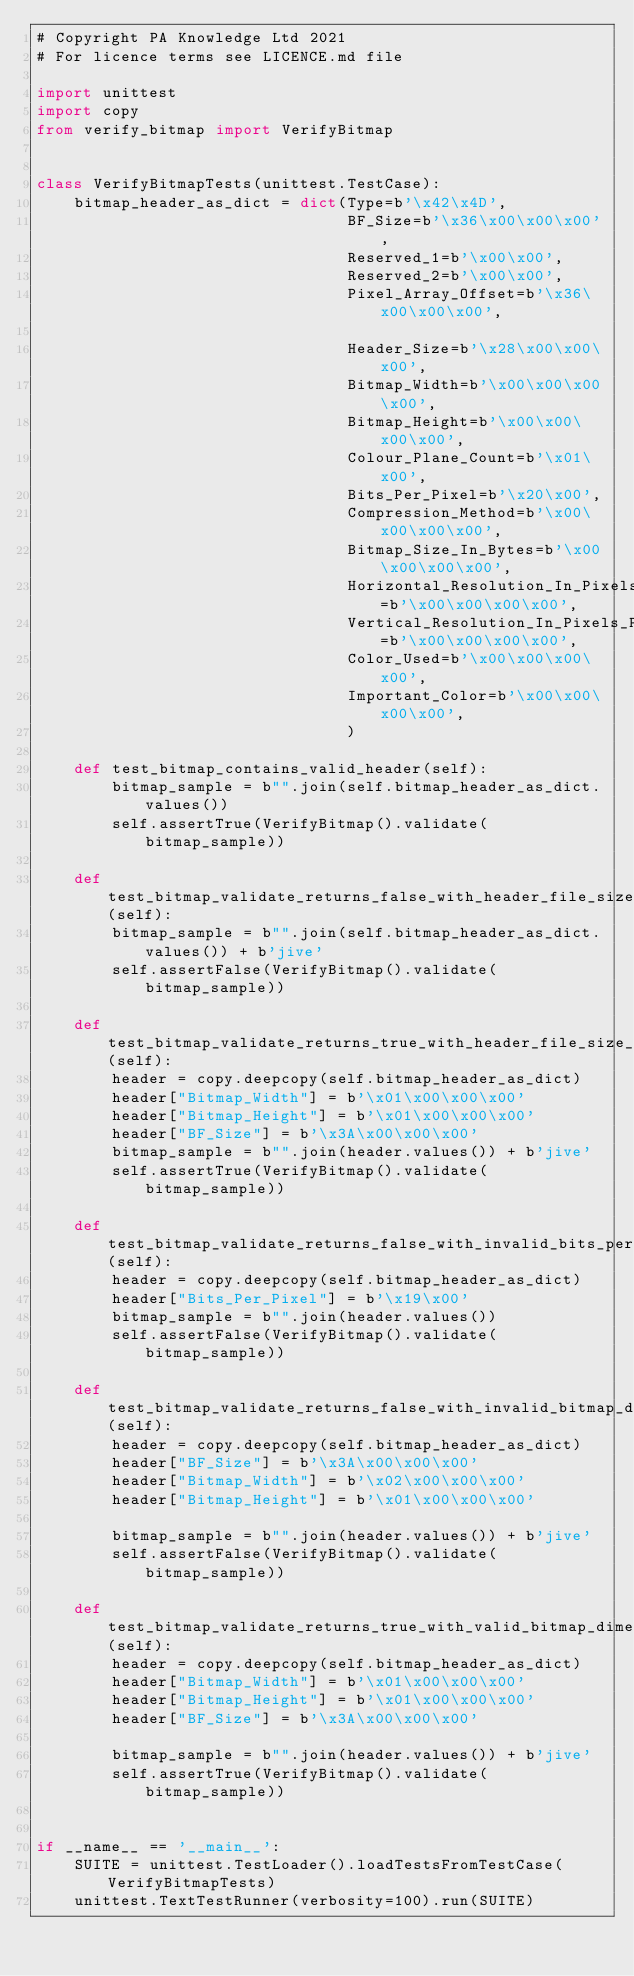Convert code to text. <code><loc_0><loc_0><loc_500><loc_500><_Python_># Copyright PA Knowledge Ltd 2021
# For licence terms see LICENCE.md file

import unittest
import copy
from verify_bitmap import VerifyBitmap


class VerifyBitmapTests(unittest.TestCase):
    bitmap_header_as_dict = dict(Type=b'\x42\x4D',
                                 BF_Size=b'\x36\x00\x00\x00',
                                 Reserved_1=b'\x00\x00',
                                 Reserved_2=b'\x00\x00',
                                 Pixel_Array_Offset=b'\x36\x00\x00\x00',

                                 Header_Size=b'\x28\x00\x00\x00',
                                 Bitmap_Width=b'\x00\x00\x00\x00',
                                 Bitmap_Height=b'\x00\x00\x00\x00',
                                 Colour_Plane_Count=b'\x01\x00',
                                 Bits_Per_Pixel=b'\x20\x00',
                                 Compression_Method=b'\x00\x00\x00\x00',
                                 Bitmap_Size_In_Bytes=b'\x00\x00\x00\x00',
                                 Horizontal_Resolution_In_Pixels_Per_Meter=b'\x00\x00\x00\x00',
                                 Vertical_Resolution_In_Pixels_Per_Meter=b'\x00\x00\x00\x00',
                                 Color_Used=b'\x00\x00\x00\x00',
                                 Important_Color=b'\x00\x00\x00\x00',
                                 )

    def test_bitmap_contains_valid_header(self):
        bitmap_sample = b"".join(self.bitmap_header_as_dict.values())
        self.assertTrue(VerifyBitmap().validate(bitmap_sample))

    def test_bitmap_validate_returns_false_with_header_file_size_not_equal_to_data_length(self):
        bitmap_sample = b"".join(self.bitmap_header_as_dict.values()) + b'jive'
        self.assertFalse(VerifyBitmap().validate(bitmap_sample))

    def test_bitmap_validate_returns_true_with_header_file_size_equal_to_data_length(self):
        header = copy.deepcopy(self.bitmap_header_as_dict)
        header["Bitmap_Width"] = b'\x01\x00\x00\x00'
        header["Bitmap_Height"] = b'\x01\x00\x00\x00'
        header["BF_Size"] = b'\x3A\x00\x00\x00'
        bitmap_sample = b"".join(header.values()) + b'jive'
        self.assertTrue(VerifyBitmap().validate(bitmap_sample))

    def test_bitmap_validate_returns_false_with_invalid_bits_per_pixel(self):
        header = copy.deepcopy(self.bitmap_header_as_dict)
        header["Bits_Per_Pixel"] = b'\x19\x00'
        bitmap_sample = b"".join(header.values())
        self.assertFalse(VerifyBitmap().validate(bitmap_sample))

    def test_bitmap_validate_returns_false_with_invalid_bitmap_dimensions(self):
        header = copy.deepcopy(self.bitmap_header_as_dict)
        header["BF_Size"] = b'\x3A\x00\x00\x00'
        header["Bitmap_Width"] = b'\x02\x00\x00\x00'
        header["Bitmap_Height"] = b'\x01\x00\x00\x00'

        bitmap_sample = b"".join(header.values()) + b'jive'
        self.assertFalse(VerifyBitmap().validate(bitmap_sample))

    def test_bitmap_validate_returns_true_with_valid_bitmap_dimensions(self):
        header = copy.deepcopy(self.bitmap_header_as_dict)
        header["Bitmap_Width"] = b'\x01\x00\x00\x00'
        header["Bitmap_Height"] = b'\x01\x00\x00\x00'
        header["BF_Size"] = b'\x3A\x00\x00\x00'

        bitmap_sample = b"".join(header.values()) + b'jive'
        self.assertTrue(VerifyBitmap().validate(bitmap_sample))


if __name__ == '__main__':
    SUITE = unittest.TestLoader().loadTestsFromTestCase(VerifyBitmapTests)
    unittest.TextTestRunner(verbosity=100).run(SUITE)
</code> 